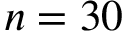Convert formula to latex. <formula><loc_0><loc_0><loc_500><loc_500>n = 3 0</formula> 